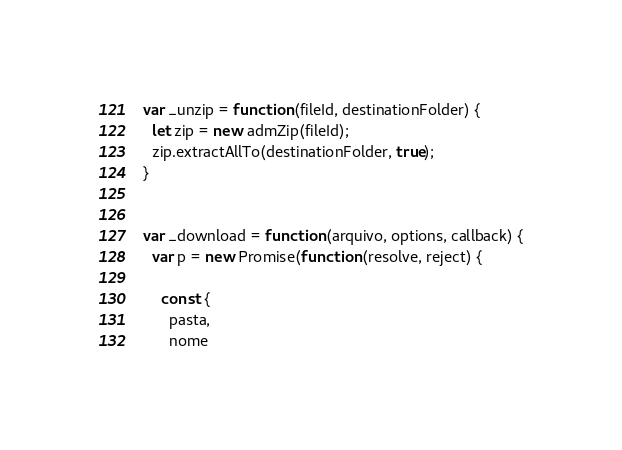Convert code to text. <code><loc_0><loc_0><loc_500><loc_500><_JavaScript_>

var _unzip = function (fileId, destinationFolder) {
  let zip = new admZip(fileId);
  zip.extractAllTo(destinationFolder, true);
}


var _download = function (arquivo, options, callback) {
  var p = new Promise(function (resolve, reject) {

    const {
      pasta,
      nome</code> 